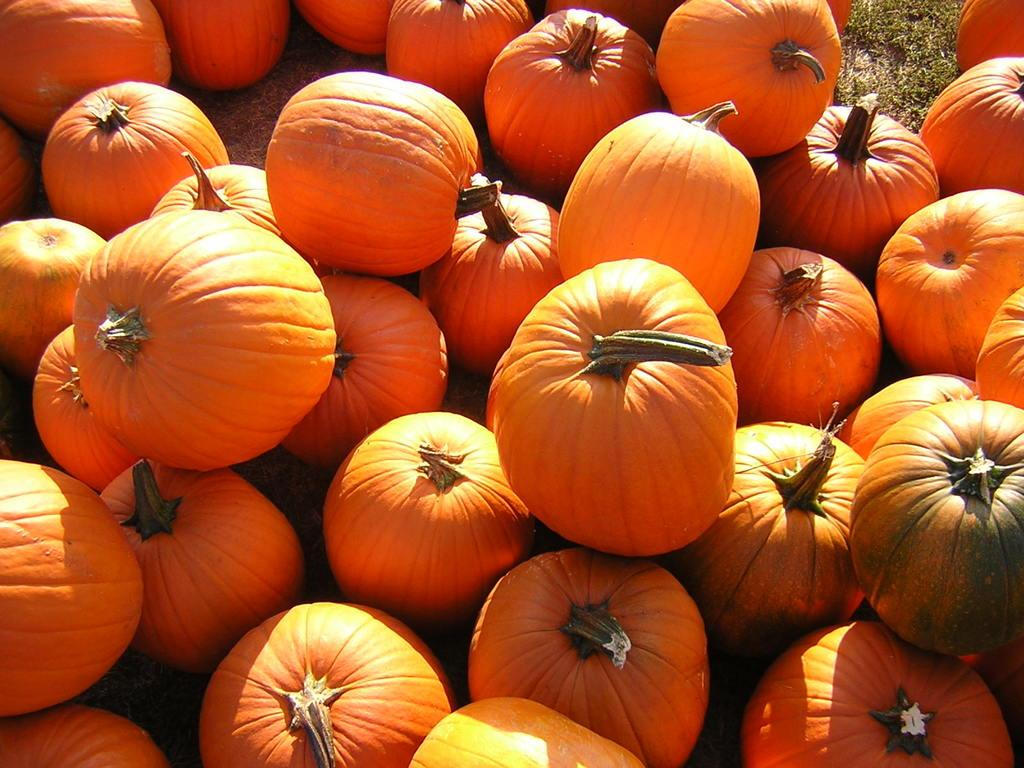What type of vegetable is present in the image? There are pumpkins in the picture. What color are the pumpkins? The pumpkins are in orange color. Can you see a person ordering a pencil in the image? There is no person or pencil present in the image; it only features pumpkins. 